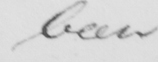Please transcribe the handwritten text in this image. been 